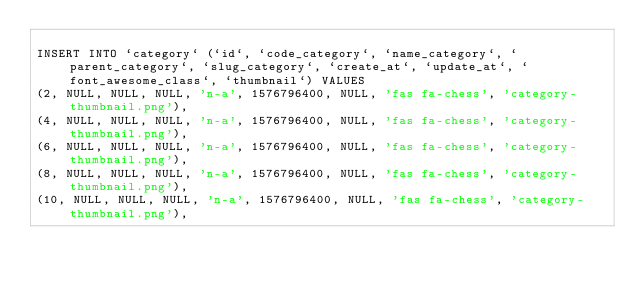Convert code to text. <code><loc_0><loc_0><loc_500><loc_500><_SQL_>
INSERT INTO `category` (`id`, `code_category`, `name_category`, `parent_category`, `slug_category`, `create_at`, `update_at`, `font_awesome_class`, `thumbnail`) VALUES
(2, NULL, NULL, NULL, 'n-a', 1576796400, NULL, 'fas fa-chess', 'category-thumbnail.png'),
(4, NULL, NULL, NULL, 'n-a', 1576796400, NULL, 'fas fa-chess', 'category-thumbnail.png'),
(6, NULL, NULL, NULL, 'n-a', 1576796400, NULL, 'fas fa-chess', 'category-thumbnail.png'),
(8, NULL, NULL, NULL, 'n-a', 1576796400, NULL, 'fas fa-chess', 'category-thumbnail.png'),
(10, NULL, NULL, NULL, 'n-a', 1576796400, NULL, 'fas fa-chess', 'category-thumbnail.png'),</code> 